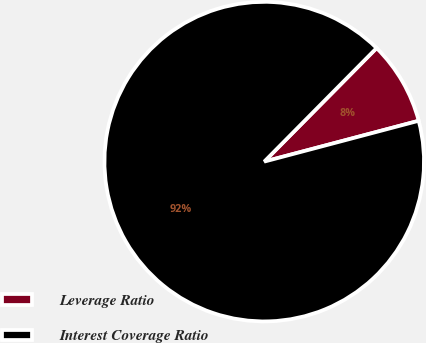Convert chart to OTSL. <chart><loc_0><loc_0><loc_500><loc_500><pie_chart><fcel>Leverage Ratio<fcel>Interest Coverage Ratio<nl><fcel>8.47%<fcel>91.53%<nl></chart> 